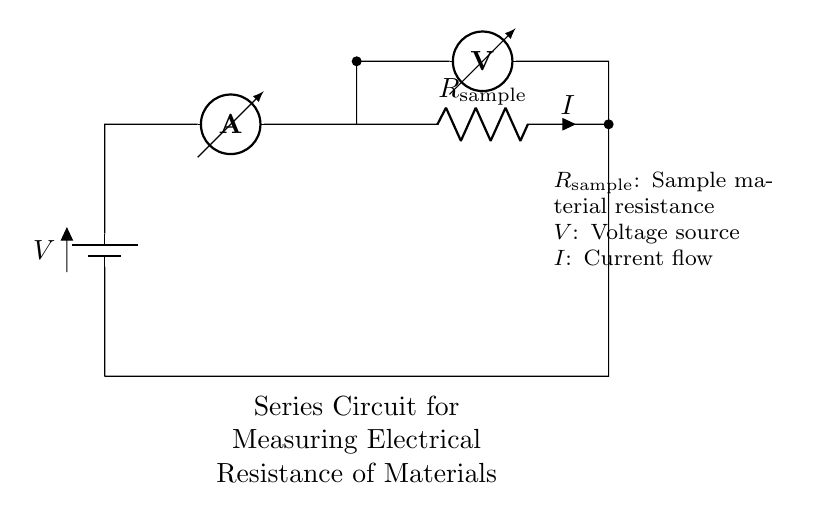What type of circuit is depicted? The circuit is a series circuit, in which components are connected in a single path, and the current flows through each component sequentially. This type can be identified by the specific arrangement of components and the lack of parallel branches.
Answer: Series circuit What is the purpose of the ammeter in this circuit? The ammeter measures the current flowing through the circuit. Its position in series ensures that all current passing through the circuit also passes through the ammeter, allowing for accurate measurements.
Answer: Measure current What does the voltmeter measure in the circuit? The voltmeter measures the voltage drop across the sample resistance. It is positioned parallel to the sample resistor, which allows it to measure how much electrical potential is lost as current passes through the resistor.
Answer: Voltage across sample If the voltage source is 10 volts and the current measured is 2 amperes, what is the resistance of the sample? According to Ohm's Law (V=IR), resistance can be calculated by rearranging the formula to R = V/I. Plugging in the values, R = 10V / 2A, which results in 5 ohms for the resistance of the sample.
Answer: 5 ohms Why is it important to have a series circuit for measuring resistance in this manner? A series circuit ensures the same current flows through all components, which is crucial for accurately measuring resistance. It simplifies the calculations as the total resistance can be directly deduced from the one resistor being measured without any complex interactions from parallel resistances.
Answer: Accurate resistance measurement What component can be adjusted to change the current in the circuit? The voltage source can be adjusted to change the current. By increasing or decreasing the voltage applied across the components, the amount of current flowing through the circuit can be altered according to Ohm's Law.
Answer: Voltage source 